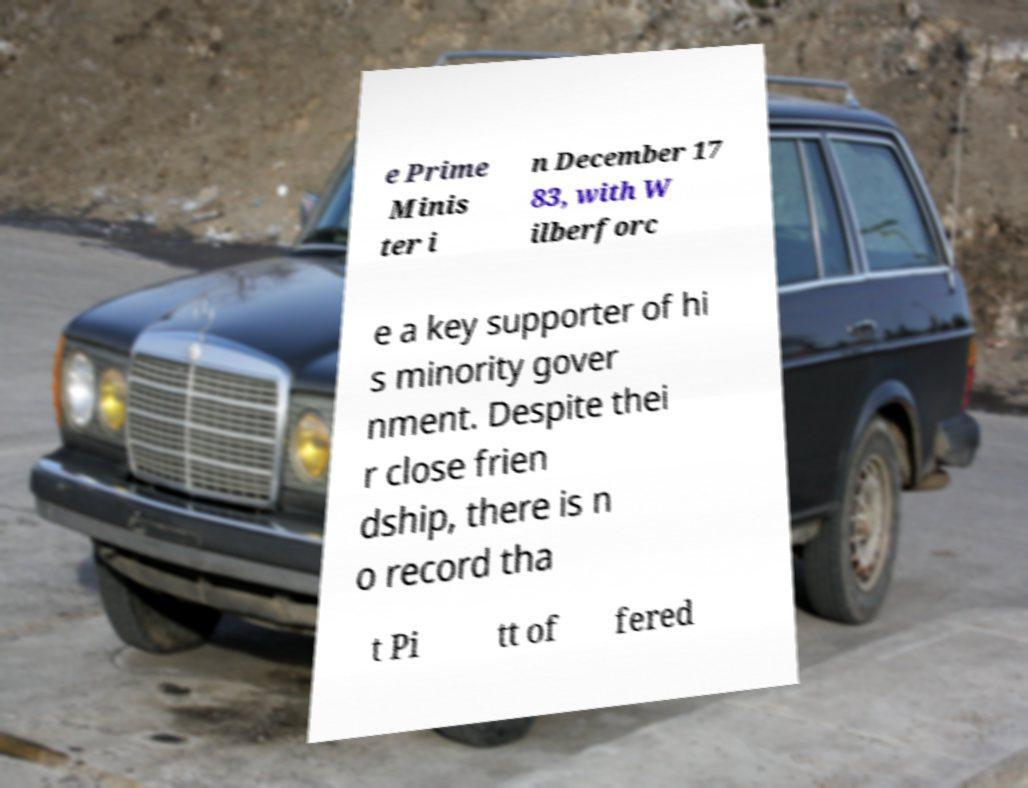There's text embedded in this image that I need extracted. Can you transcribe it verbatim? e Prime Minis ter i n December 17 83, with W ilberforc e a key supporter of hi s minority gover nment. Despite thei r close frien dship, there is n o record tha t Pi tt of fered 